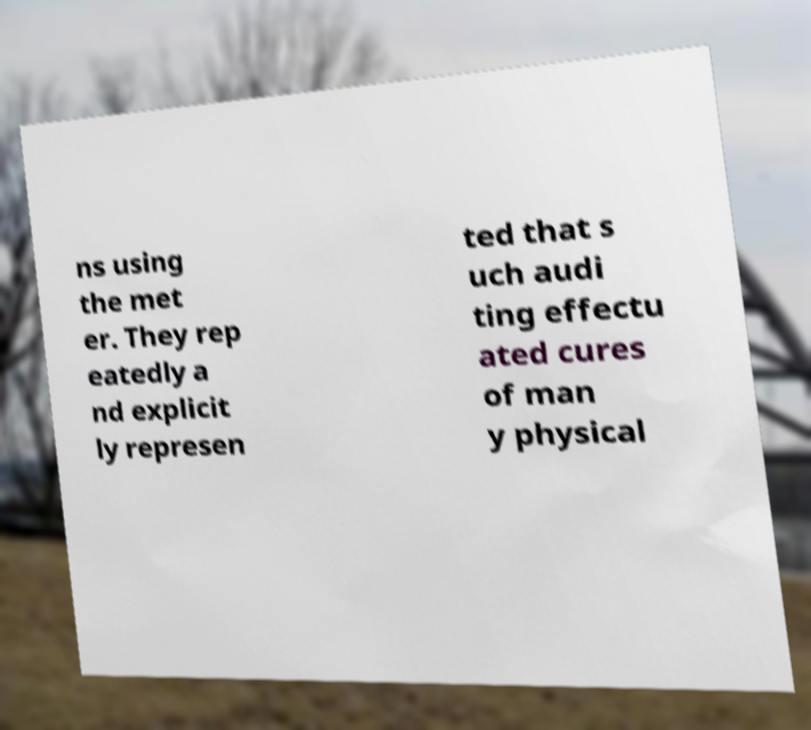Could you extract and type out the text from this image? ns using the met er. They rep eatedly a nd explicit ly represen ted that s uch audi ting effectu ated cures of man y physical 